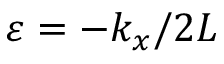<formula> <loc_0><loc_0><loc_500><loc_500>\varepsilon = - k _ { x } / 2 L</formula> 